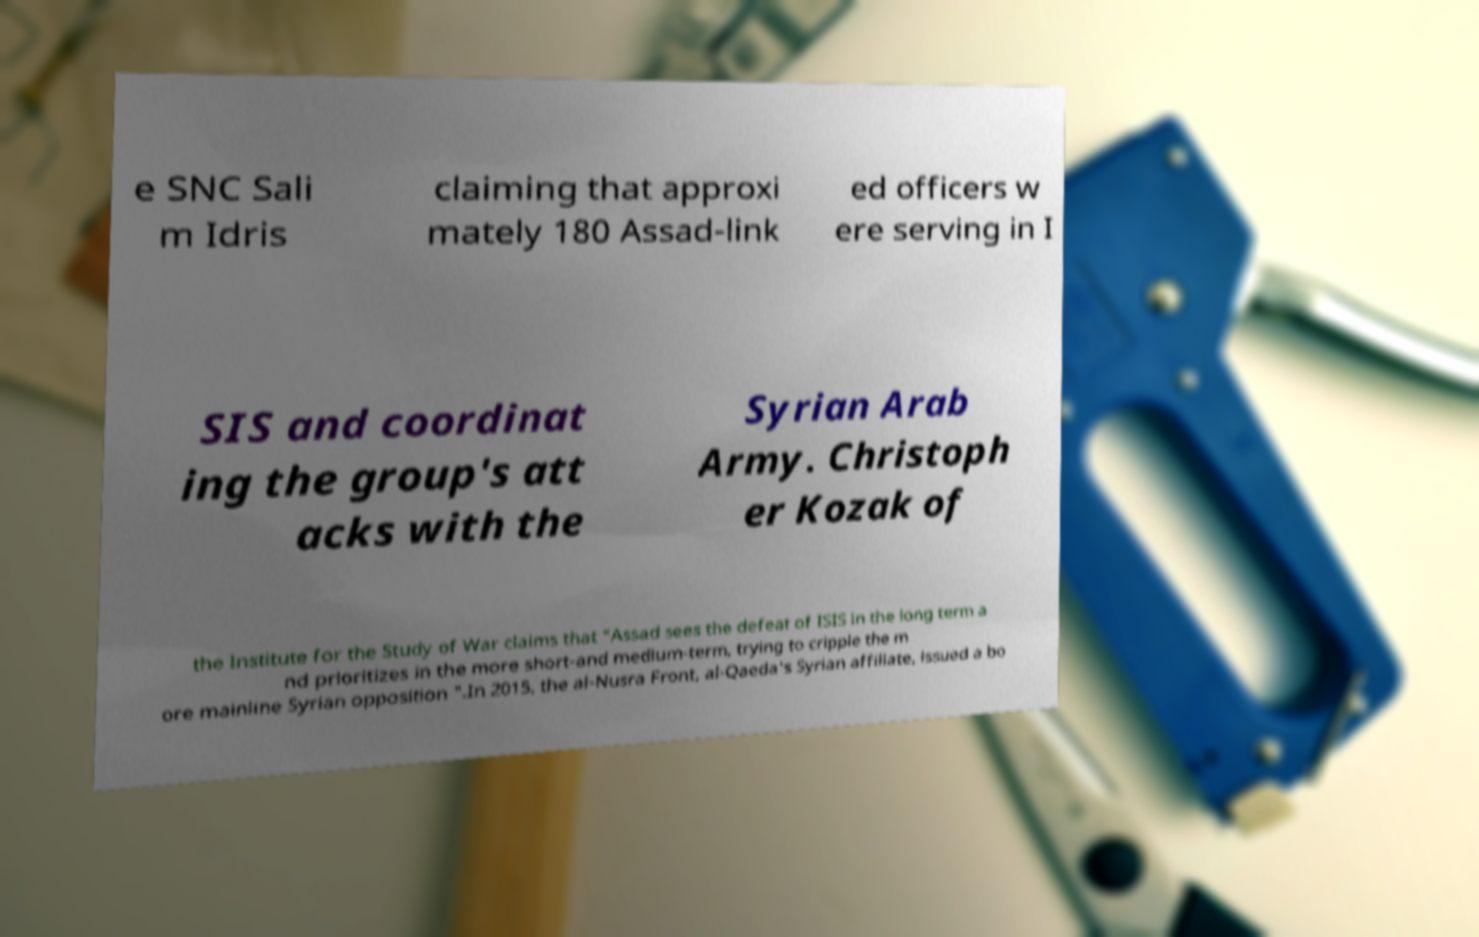Could you extract and type out the text from this image? e SNC Sali m Idris claiming that approxi mately 180 Assad-link ed officers w ere serving in I SIS and coordinat ing the group's att acks with the Syrian Arab Army. Christoph er Kozak of the Institute for the Study of War claims that "Assad sees the defeat of ISIS in the long term a nd prioritizes in the more short-and medium-term, trying to cripple the m ore mainline Syrian opposition ".In 2015, the al-Nusra Front, al-Qaeda's Syrian affiliate, issued a bo 